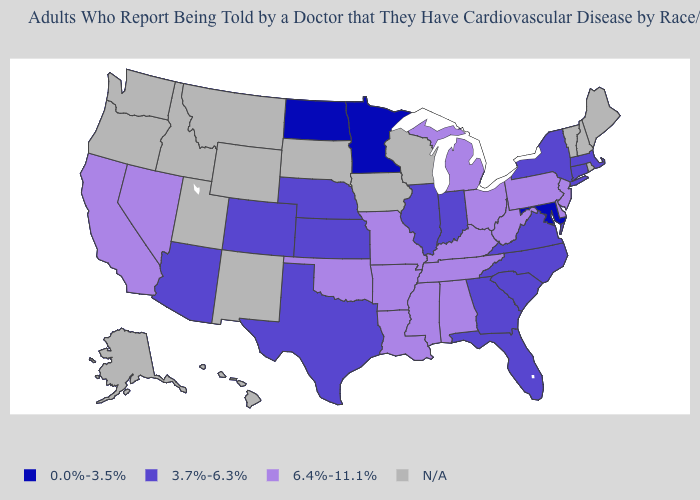Among the states that border Pennsylvania , does West Virginia have the highest value?
Keep it brief. Yes. Among the states that border South Carolina , which have the lowest value?
Quick response, please. Georgia, North Carolina. What is the value of Idaho?
Quick response, please. N/A. What is the value of New Hampshire?
Keep it brief. N/A. Name the states that have a value in the range 3.7%-6.3%?
Answer briefly. Arizona, Colorado, Connecticut, Florida, Georgia, Illinois, Indiana, Kansas, Massachusetts, Nebraska, New York, North Carolina, South Carolina, Texas, Virginia. Name the states that have a value in the range N/A?
Keep it brief. Alaska, Hawaii, Idaho, Iowa, Maine, Montana, New Hampshire, New Mexico, Oregon, Rhode Island, South Dakota, Utah, Vermont, Washington, Wisconsin, Wyoming. What is the value of South Carolina?
Quick response, please. 3.7%-6.3%. Does Colorado have the highest value in the West?
Keep it brief. No. What is the lowest value in the Northeast?
Be succinct. 3.7%-6.3%. Which states have the lowest value in the USA?
Quick response, please. Maryland, Minnesota, North Dakota. What is the value of Ohio?
Short answer required. 6.4%-11.1%. What is the value of Maine?
Concise answer only. N/A. 